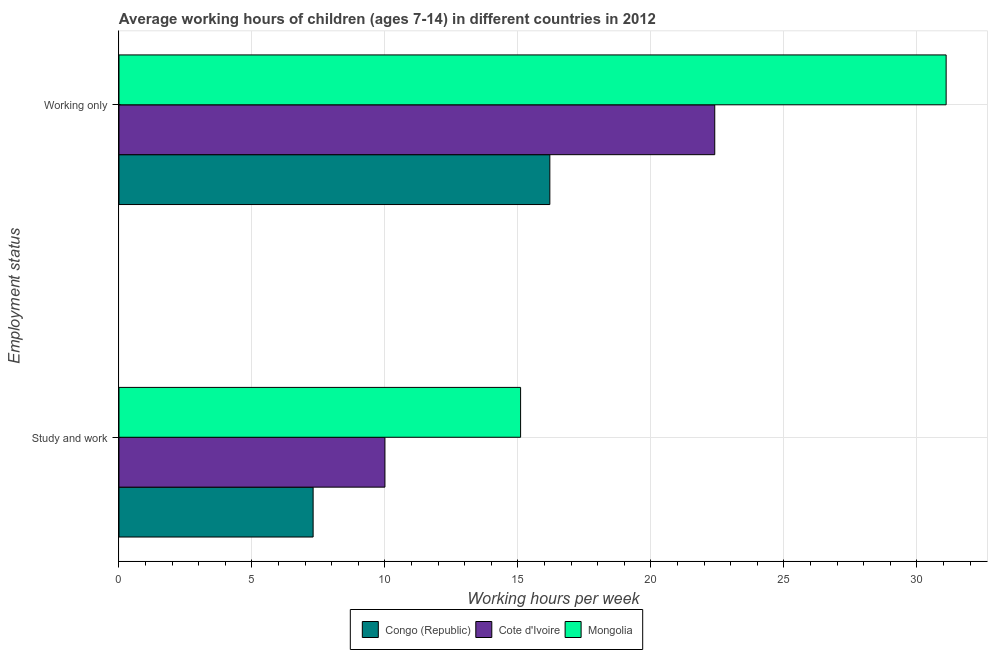How many different coloured bars are there?
Offer a very short reply. 3. How many groups of bars are there?
Give a very brief answer. 2. Are the number of bars per tick equal to the number of legend labels?
Offer a very short reply. Yes. Are the number of bars on each tick of the Y-axis equal?
Your answer should be compact. Yes. How many bars are there on the 1st tick from the top?
Keep it short and to the point. 3. How many bars are there on the 2nd tick from the bottom?
Make the answer very short. 3. What is the label of the 1st group of bars from the top?
Your answer should be very brief. Working only. Across all countries, what is the minimum average working hour of children involved in study and work?
Your answer should be compact. 7.3. In which country was the average working hour of children involved in study and work maximum?
Keep it short and to the point. Mongolia. In which country was the average working hour of children involved in only work minimum?
Make the answer very short. Congo (Republic). What is the total average working hour of children involved in only work in the graph?
Ensure brevity in your answer.  69.7. What is the difference between the average working hour of children involved in study and work in Mongolia and that in Congo (Republic)?
Your response must be concise. 7.8. What is the difference between the average working hour of children involved in study and work in Cote d'Ivoire and the average working hour of children involved in only work in Mongolia?
Keep it short and to the point. -21.1. What is the average average working hour of children involved in only work per country?
Offer a very short reply. 23.23. What is the difference between the average working hour of children involved in only work and average working hour of children involved in study and work in Cote d'Ivoire?
Give a very brief answer. 12.4. In how many countries, is the average working hour of children involved in only work greater than 11 hours?
Your response must be concise. 3. What is the ratio of the average working hour of children involved in study and work in Cote d'Ivoire to that in Mongolia?
Your response must be concise. 0.66. What does the 3rd bar from the top in Working only represents?
Your answer should be very brief. Congo (Republic). What does the 3rd bar from the bottom in Study and work represents?
Provide a succinct answer. Mongolia. How many bars are there?
Your response must be concise. 6. Are all the bars in the graph horizontal?
Your response must be concise. Yes. How many countries are there in the graph?
Keep it short and to the point. 3. What is the difference between two consecutive major ticks on the X-axis?
Your answer should be compact. 5. Where does the legend appear in the graph?
Provide a succinct answer. Bottom center. How are the legend labels stacked?
Ensure brevity in your answer.  Horizontal. What is the title of the graph?
Ensure brevity in your answer.  Average working hours of children (ages 7-14) in different countries in 2012. What is the label or title of the X-axis?
Your answer should be very brief. Working hours per week. What is the label or title of the Y-axis?
Ensure brevity in your answer.  Employment status. What is the Working hours per week in Cote d'Ivoire in Study and work?
Ensure brevity in your answer.  10. What is the Working hours per week in Mongolia in Study and work?
Your answer should be very brief. 15.1. What is the Working hours per week in Congo (Republic) in Working only?
Make the answer very short. 16.2. What is the Working hours per week in Cote d'Ivoire in Working only?
Your answer should be compact. 22.4. What is the Working hours per week in Mongolia in Working only?
Your answer should be compact. 31.1. Across all Employment status, what is the maximum Working hours per week in Congo (Republic)?
Your answer should be compact. 16.2. Across all Employment status, what is the maximum Working hours per week in Cote d'Ivoire?
Ensure brevity in your answer.  22.4. Across all Employment status, what is the maximum Working hours per week of Mongolia?
Ensure brevity in your answer.  31.1. Across all Employment status, what is the minimum Working hours per week in Congo (Republic)?
Offer a terse response. 7.3. Across all Employment status, what is the minimum Working hours per week of Mongolia?
Offer a terse response. 15.1. What is the total Working hours per week of Cote d'Ivoire in the graph?
Give a very brief answer. 32.4. What is the total Working hours per week in Mongolia in the graph?
Provide a succinct answer. 46.2. What is the difference between the Working hours per week in Mongolia in Study and work and that in Working only?
Keep it short and to the point. -16. What is the difference between the Working hours per week of Congo (Republic) in Study and work and the Working hours per week of Cote d'Ivoire in Working only?
Keep it short and to the point. -15.1. What is the difference between the Working hours per week of Congo (Republic) in Study and work and the Working hours per week of Mongolia in Working only?
Provide a short and direct response. -23.8. What is the difference between the Working hours per week in Cote d'Ivoire in Study and work and the Working hours per week in Mongolia in Working only?
Your answer should be very brief. -21.1. What is the average Working hours per week of Congo (Republic) per Employment status?
Keep it short and to the point. 11.75. What is the average Working hours per week in Cote d'Ivoire per Employment status?
Give a very brief answer. 16.2. What is the average Working hours per week in Mongolia per Employment status?
Your response must be concise. 23.1. What is the difference between the Working hours per week in Congo (Republic) and Working hours per week in Cote d'Ivoire in Study and work?
Provide a short and direct response. -2.7. What is the difference between the Working hours per week in Cote d'Ivoire and Working hours per week in Mongolia in Study and work?
Your response must be concise. -5.1. What is the difference between the Working hours per week of Congo (Republic) and Working hours per week of Cote d'Ivoire in Working only?
Make the answer very short. -6.2. What is the difference between the Working hours per week in Congo (Republic) and Working hours per week in Mongolia in Working only?
Offer a terse response. -14.9. What is the difference between the Working hours per week in Cote d'Ivoire and Working hours per week in Mongolia in Working only?
Provide a succinct answer. -8.7. What is the ratio of the Working hours per week in Congo (Republic) in Study and work to that in Working only?
Make the answer very short. 0.45. What is the ratio of the Working hours per week in Cote d'Ivoire in Study and work to that in Working only?
Offer a very short reply. 0.45. What is the ratio of the Working hours per week of Mongolia in Study and work to that in Working only?
Your answer should be very brief. 0.49. What is the difference between the highest and the second highest Working hours per week of Cote d'Ivoire?
Give a very brief answer. 12.4. What is the difference between the highest and the second highest Working hours per week in Mongolia?
Offer a terse response. 16. What is the difference between the highest and the lowest Working hours per week of Cote d'Ivoire?
Make the answer very short. 12.4. What is the difference between the highest and the lowest Working hours per week in Mongolia?
Offer a very short reply. 16. 